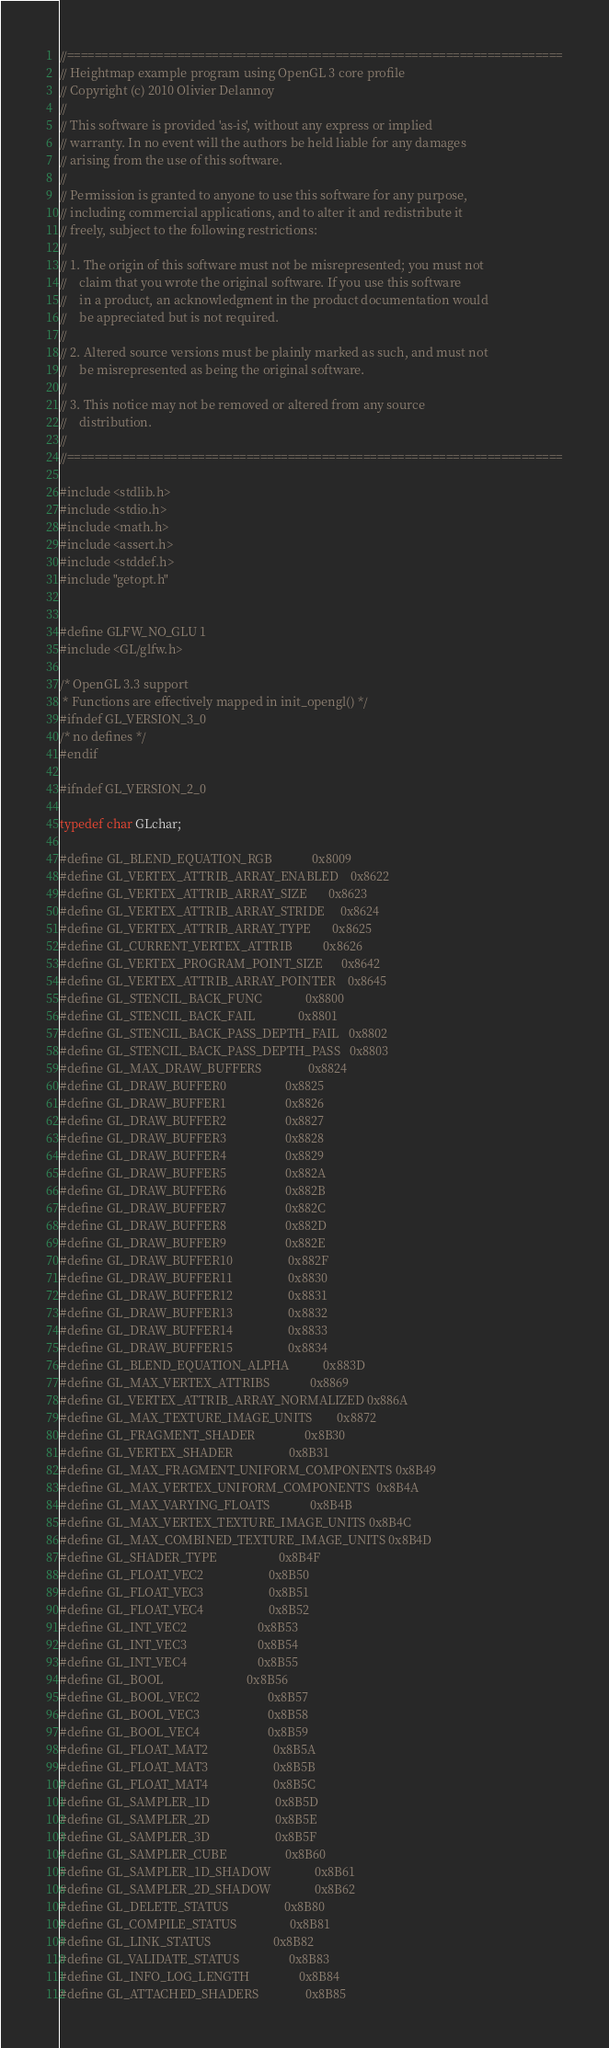Convert code to text. <code><loc_0><loc_0><loc_500><loc_500><_C_>//========================================================================
// Heightmap example program using OpenGL 3 core profile
// Copyright (c) 2010 Olivier Delannoy
//
// This software is provided 'as-is', without any express or implied
// warranty. In no event will the authors be held liable for any damages
// arising from the use of this software.
//
// Permission is granted to anyone to use this software for any purpose,
// including commercial applications, and to alter it and redistribute it
// freely, subject to the following restrictions:
//
// 1. The origin of this software must not be misrepresented; you must not
//    claim that you wrote the original software. If you use this software
//    in a product, an acknowledgment in the product documentation would
//    be appreciated but is not required.
//
// 2. Altered source versions must be plainly marked as such, and must not
//    be misrepresented as being the original software.
//
// 3. This notice may not be removed or altered from any source
//    distribution.
//
//========================================================================

#include <stdlib.h>
#include <stdio.h>
#include <math.h>
#include <assert.h>
#include <stddef.h>
#include "getopt.h"


#define GLFW_NO_GLU 1 
#include <GL/glfw.h>

/* OpenGL 3.3 support  
 * Functions are effectively mapped in init_opengl() */
#ifndef GL_VERSION_3_0
/* no defines */
#endif

#ifndef GL_VERSION_2_0

typedef char GLchar;

#define GL_BLEND_EQUATION_RGB             0x8009
#define GL_VERTEX_ATTRIB_ARRAY_ENABLED    0x8622
#define GL_VERTEX_ATTRIB_ARRAY_SIZE       0x8623
#define GL_VERTEX_ATTRIB_ARRAY_STRIDE     0x8624
#define GL_VERTEX_ATTRIB_ARRAY_TYPE       0x8625
#define GL_CURRENT_VERTEX_ATTRIB          0x8626
#define GL_VERTEX_PROGRAM_POINT_SIZE      0x8642
#define GL_VERTEX_ATTRIB_ARRAY_POINTER    0x8645
#define GL_STENCIL_BACK_FUNC              0x8800
#define GL_STENCIL_BACK_FAIL              0x8801
#define GL_STENCIL_BACK_PASS_DEPTH_FAIL   0x8802
#define GL_STENCIL_BACK_PASS_DEPTH_PASS   0x8803
#define GL_MAX_DRAW_BUFFERS               0x8824
#define GL_DRAW_BUFFER0                   0x8825
#define GL_DRAW_BUFFER1                   0x8826
#define GL_DRAW_BUFFER2                   0x8827
#define GL_DRAW_BUFFER3                   0x8828
#define GL_DRAW_BUFFER4                   0x8829
#define GL_DRAW_BUFFER5                   0x882A
#define GL_DRAW_BUFFER6                   0x882B
#define GL_DRAW_BUFFER7                   0x882C
#define GL_DRAW_BUFFER8                   0x882D
#define GL_DRAW_BUFFER9                   0x882E
#define GL_DRAW_BUFFER10                  0x882F
#define GL_DRAW_BUFFER11                  0x8830
#define GL_DRAW_BUFFER12                  0x8831
#define GL_DRAW_BUFFER13                  0x8832
#define GL_DRAW_BUFFER14                  0x8833
#define GL_DRAW_BUFFER15                  0x8834
#define GL_BLEND_EQUATION_ALPHA           0x883D
#define GL_MAX_VERTEX_ATTRIBS             0x8869
#define GL_VERTEX_ATTRIB_ARRAY_NORMALIZED 0x886A
#define GL_MAX_TEXTURE_IMAGE_UNITS        0x8872
#define GL_FRAGMENT_SHADER                0x8B30
#define GL_VERTEX_SHADER                  0x8B31
#define GL_MAX_FRAGMENT_UNIFORM_COMPONENTS 0x8B49
#define GL_MAX_VERTEX_UNIFORM_COMPONENTS  0x8B4A
#define GL_MAX_VARYING_FLOATS             0x8B4B
#define GL_MAX_VERTEX_TEXTURE_IMAGE_UNITS 0x8B4C
#define GL_MAX_COMBINED_TEXTURE_IMAGE_UNITS 0x8B4D
#define GL_SHADER_TYPE                    0x8B4F
#define GL_FLOAT_VEC2                     0x8B50
#define GL_FLOAT_VEC3                     0x8B51
#define GL_FLOAT_VEC4                     0x8B52
#define GL_INT_VEC2                       0x8B53
#define GL_INT_VEC3                       0x8B54
#define GL_INT_VEC4                       0x8B55
#define GL_BOOL                           0x8B56
#define GL_BOOL_VEC2                      0x8B57
#define GL_BOOL_VEC3                      0x8B58
#define GL_BOOL_VEC4                      0x8B59
#define GL_FLOAT_MAT2                     0x8B5A
#define GL_FLOAT_MAT3                     0x8B5B
#define GL_FLOAT_MAT4                     0x8B5C
#define GL_SAMPLER_1D                     0x8B5D
#define GL_SAMPLER_2D                     0x8B5E
#define GL_SAMPLER_3D                     0x8B5F
#define GL_SAMPLER_CUBE                   0x8B60
#define GL_SAMPLER_1D_SHADOW              0x8B61
#define GL_SAMPLER_2D_SHADOW              0x8B62
#define GL_DELETE_STATUS                  0x8B80
#define GL_COMPILE_STATUS                 0x8B81
#define GL_LINK_STATUS                    0x8B82
#define GL_VALIDATE_STATUS                0x8B83
#define GL_INFO_LOG_LENGTH                0x8B84
#define GL_ATTACHED_SHADERS               0x8B85</code> 